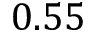Convert formula to latex. <formula><loc_0><loc_0><loc_500><loc_500>0 . 5 5</formula> 